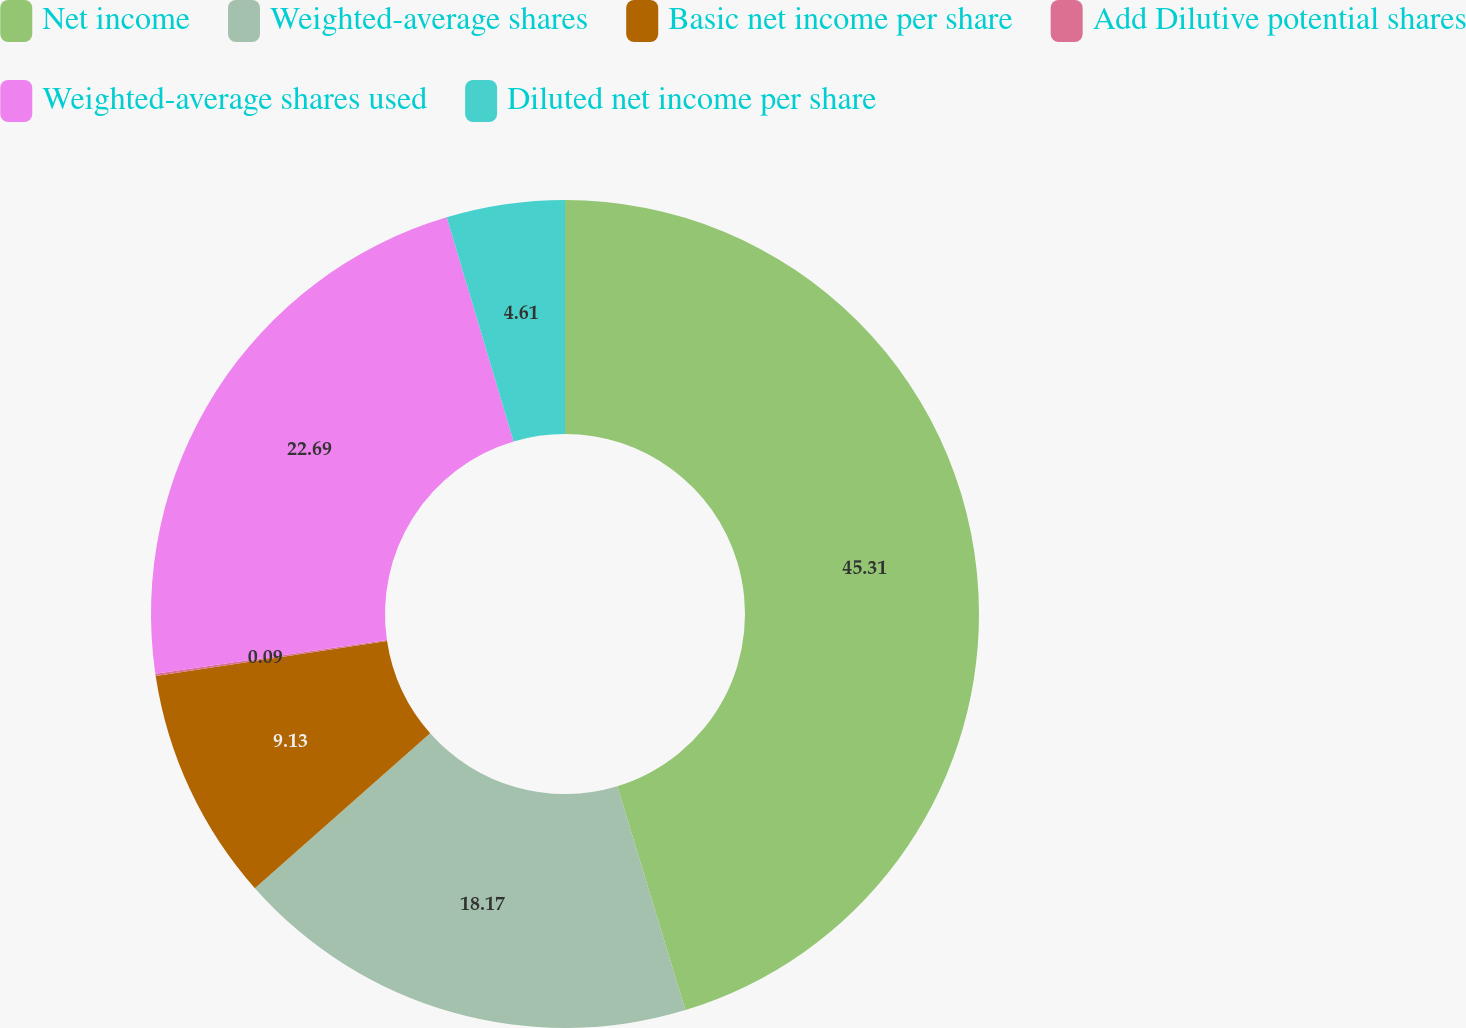<chart> <loc_0><loc_0><loc_500><loc_500><pie_chart><fcel>Net income<fcel>Weighted-average shares<fcel>Basic net income per share<fcel>Add Dilutive potential shares<fcel>Weighted-average shares used<fcel>Diluted net income per share<nl><fcel>45.3%<fcel>18.17%<fcel>9.13%<fcel>0.09%<fcel>22.69%<fcel>4.61%<nl></chart> 